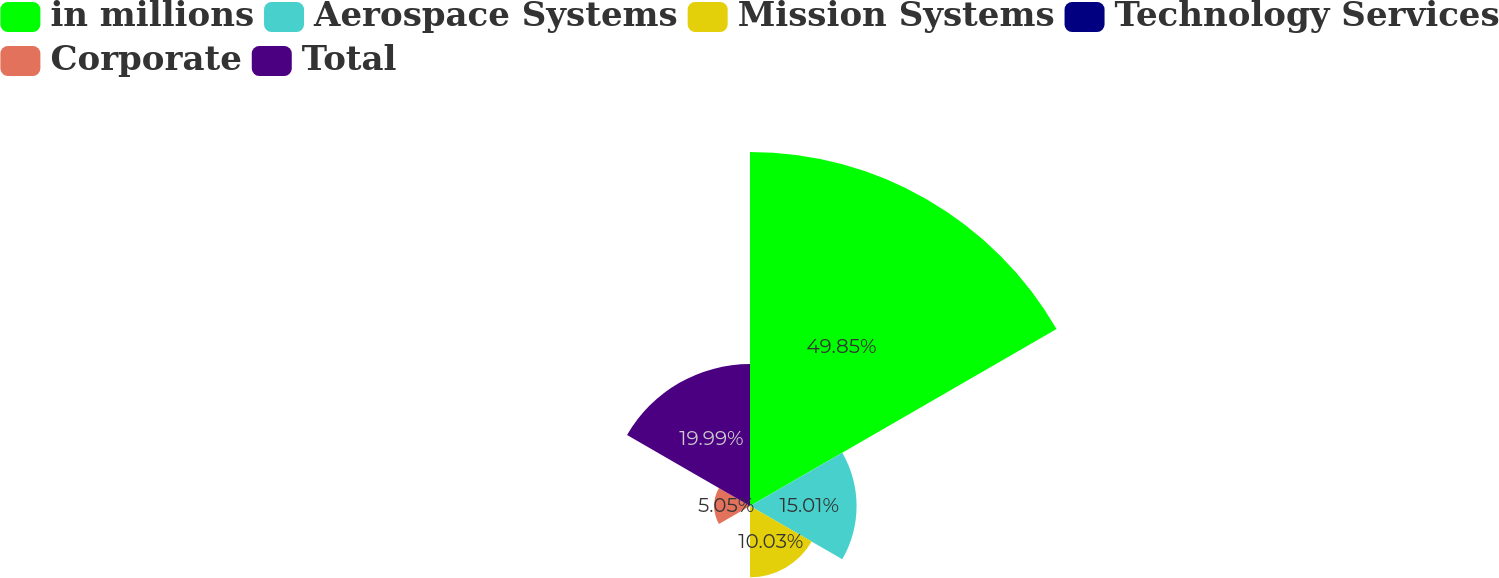<chart> <loc_0><loc_0><loc_500><loc_500><pie_chart><fcel>in millions<fcel>Aerospace Systems<fcel>Mission Systems<fcel>Technology Services<fcel>Corporate<fcel>Total<nl><fcel>49.85%<fcel>15.01%<fcel>10.03%<fcel>0.07%<fcel>5.05%<fcel>19.99%<nl></chart> 